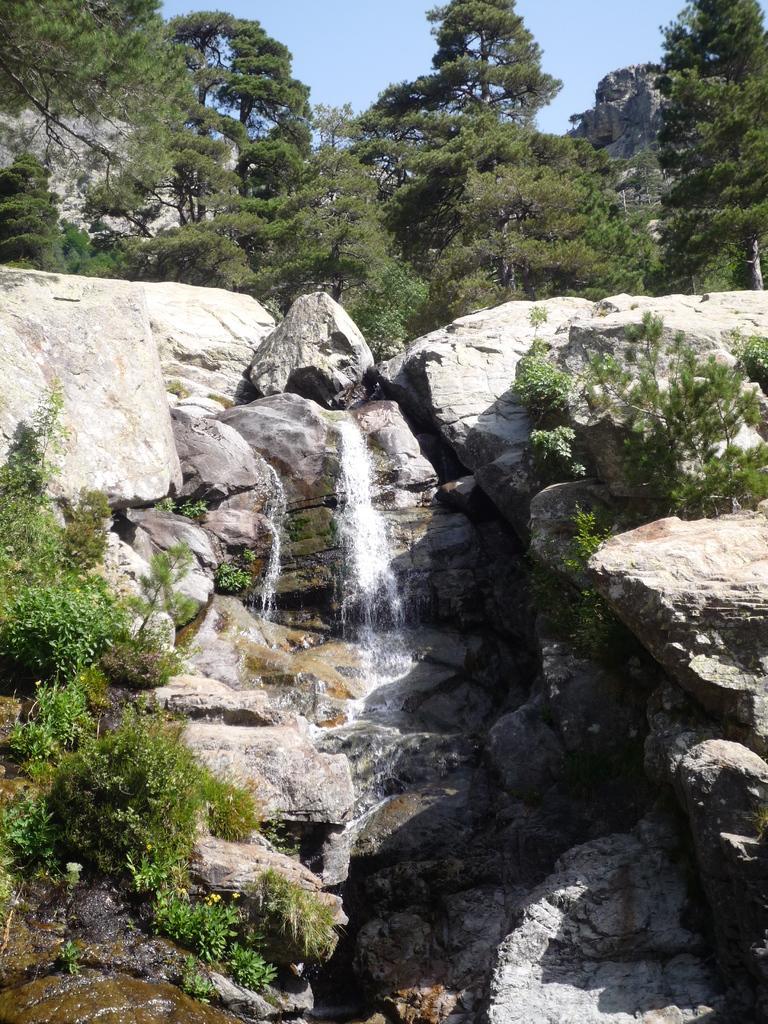In one or two sentences, can you explain what this image depicts? This picture is clicked outside the city. Here, we see waterfalls and beside that, there are many rocks. There are many trees in the background and at the top of the picture, we see the sky. 